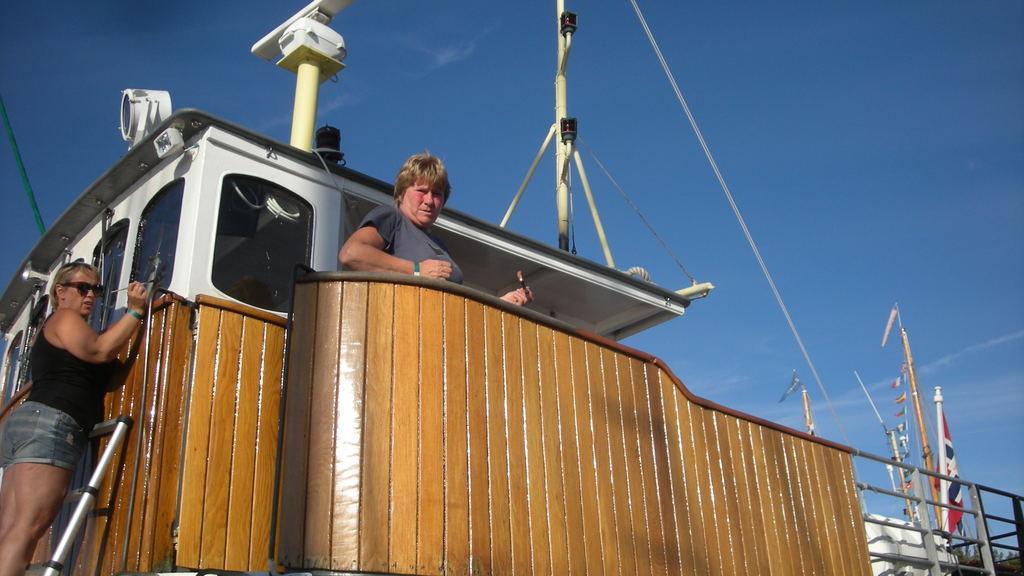In one or two sentences, can you explain what this image depicts? In this image I can see the person is standing and another person is standing on the ladder and holding something. I can see the brown color railing, poles, ropes, flags and few objects. The sky is in blue color. 